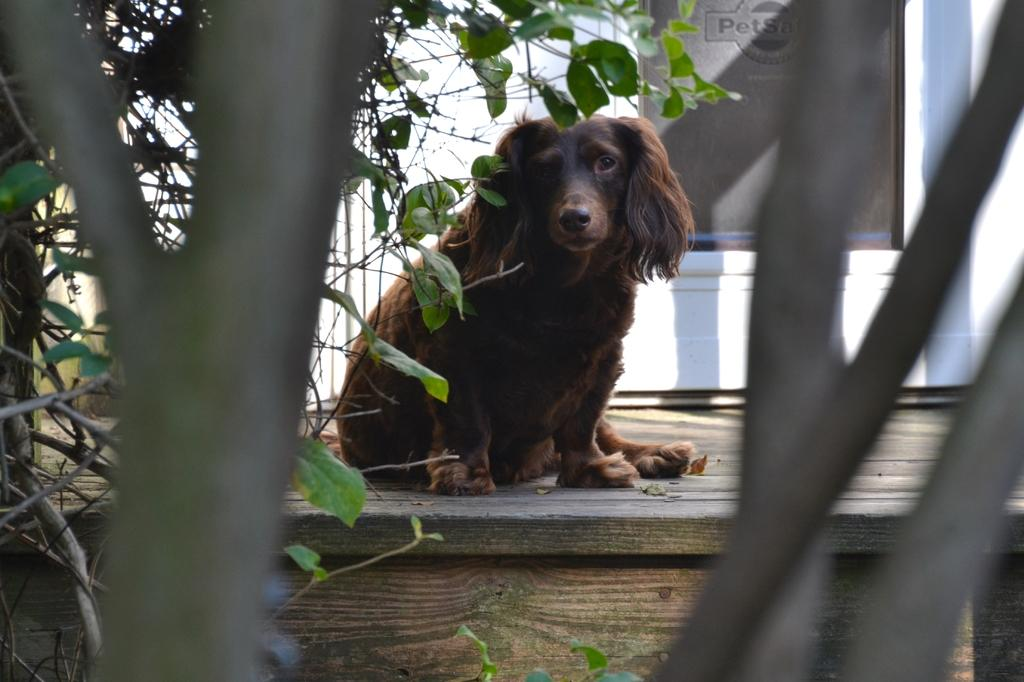What animal is on the table in the image? There is a dog on the table in the image. What can be seen in the background of the image? There is a wall and trees visible in the background of the image. What type of surface is the text written on in the background? The text is written on a stone in the background of the image. How many pears are hanging from the trees in the image? There are no pears visible in the image; only a dog, a table, a wall, and trees can be seen. 